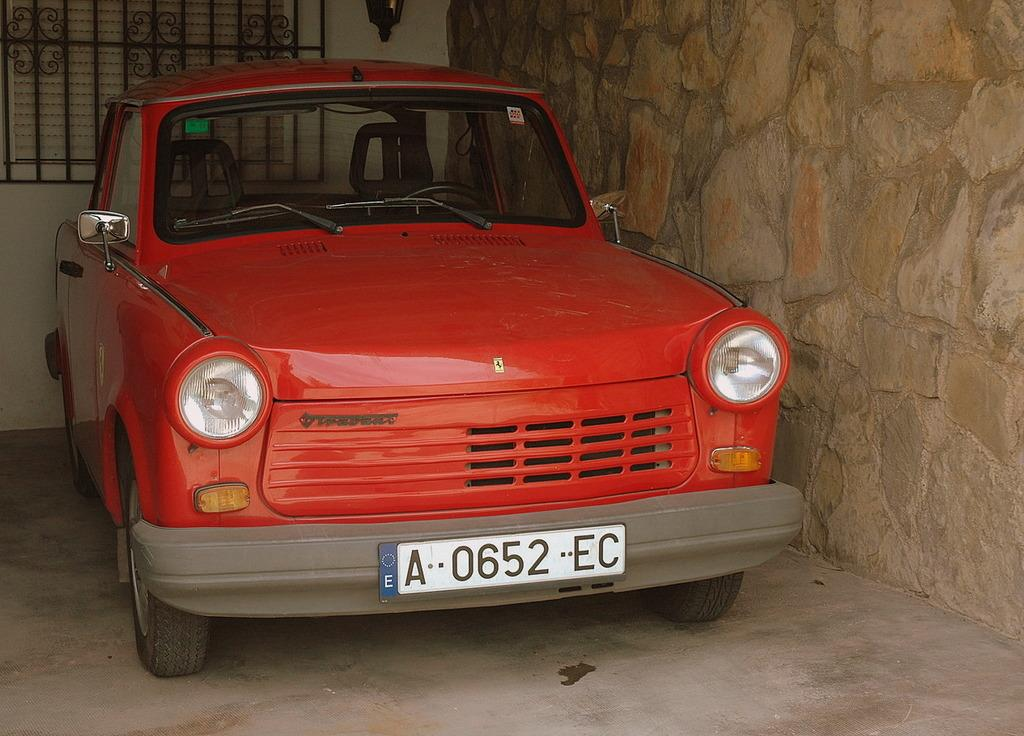What is the main subject of the image? The main subject of the image is a car. Can you describe the car's position in the image? The car is placed on a surface in the image. What other objects can be seen in the image? There is a street lamp and a metal grill on a wall in the image. What time of day is it in the image, according to the memory of the car's mom? There is no mention of a car's mom or any memory in the image, so it is not possible to determine the time of day based on that information. 